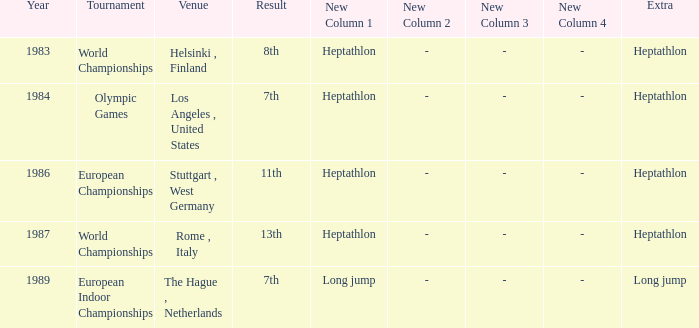How often are the Olympic games hosted? 1984.0. 